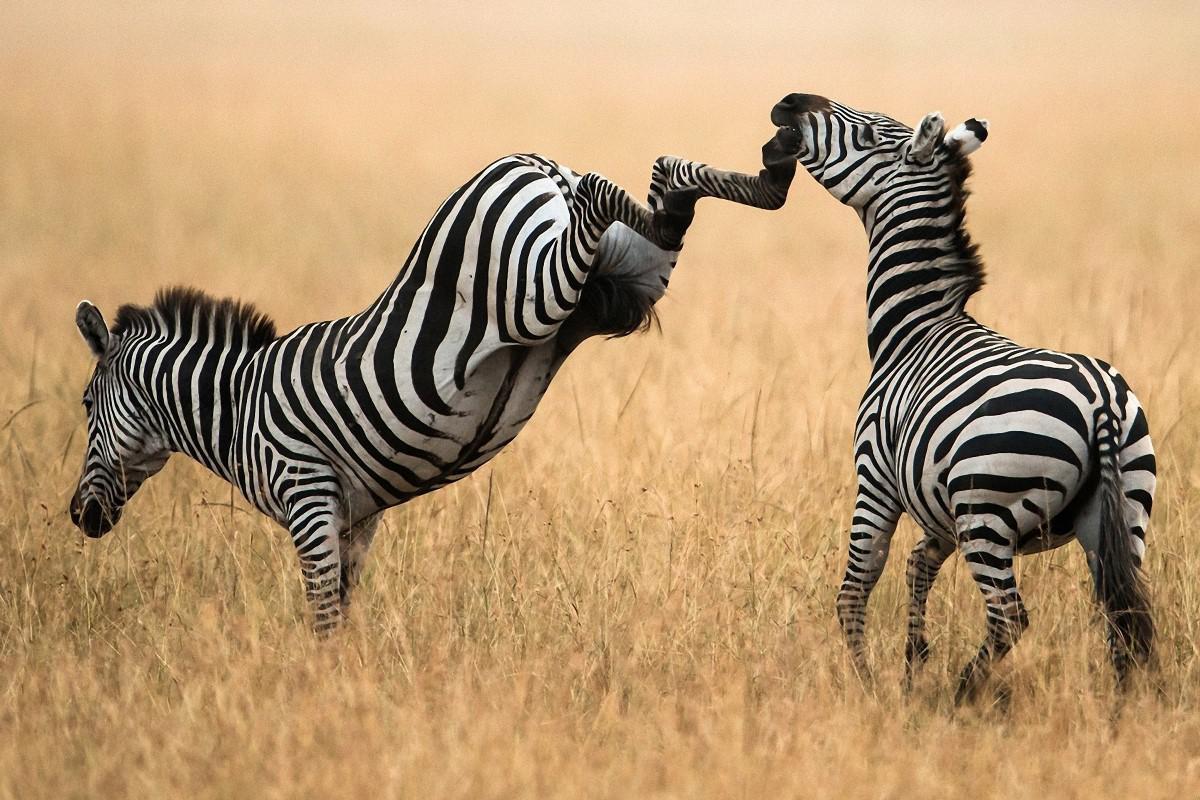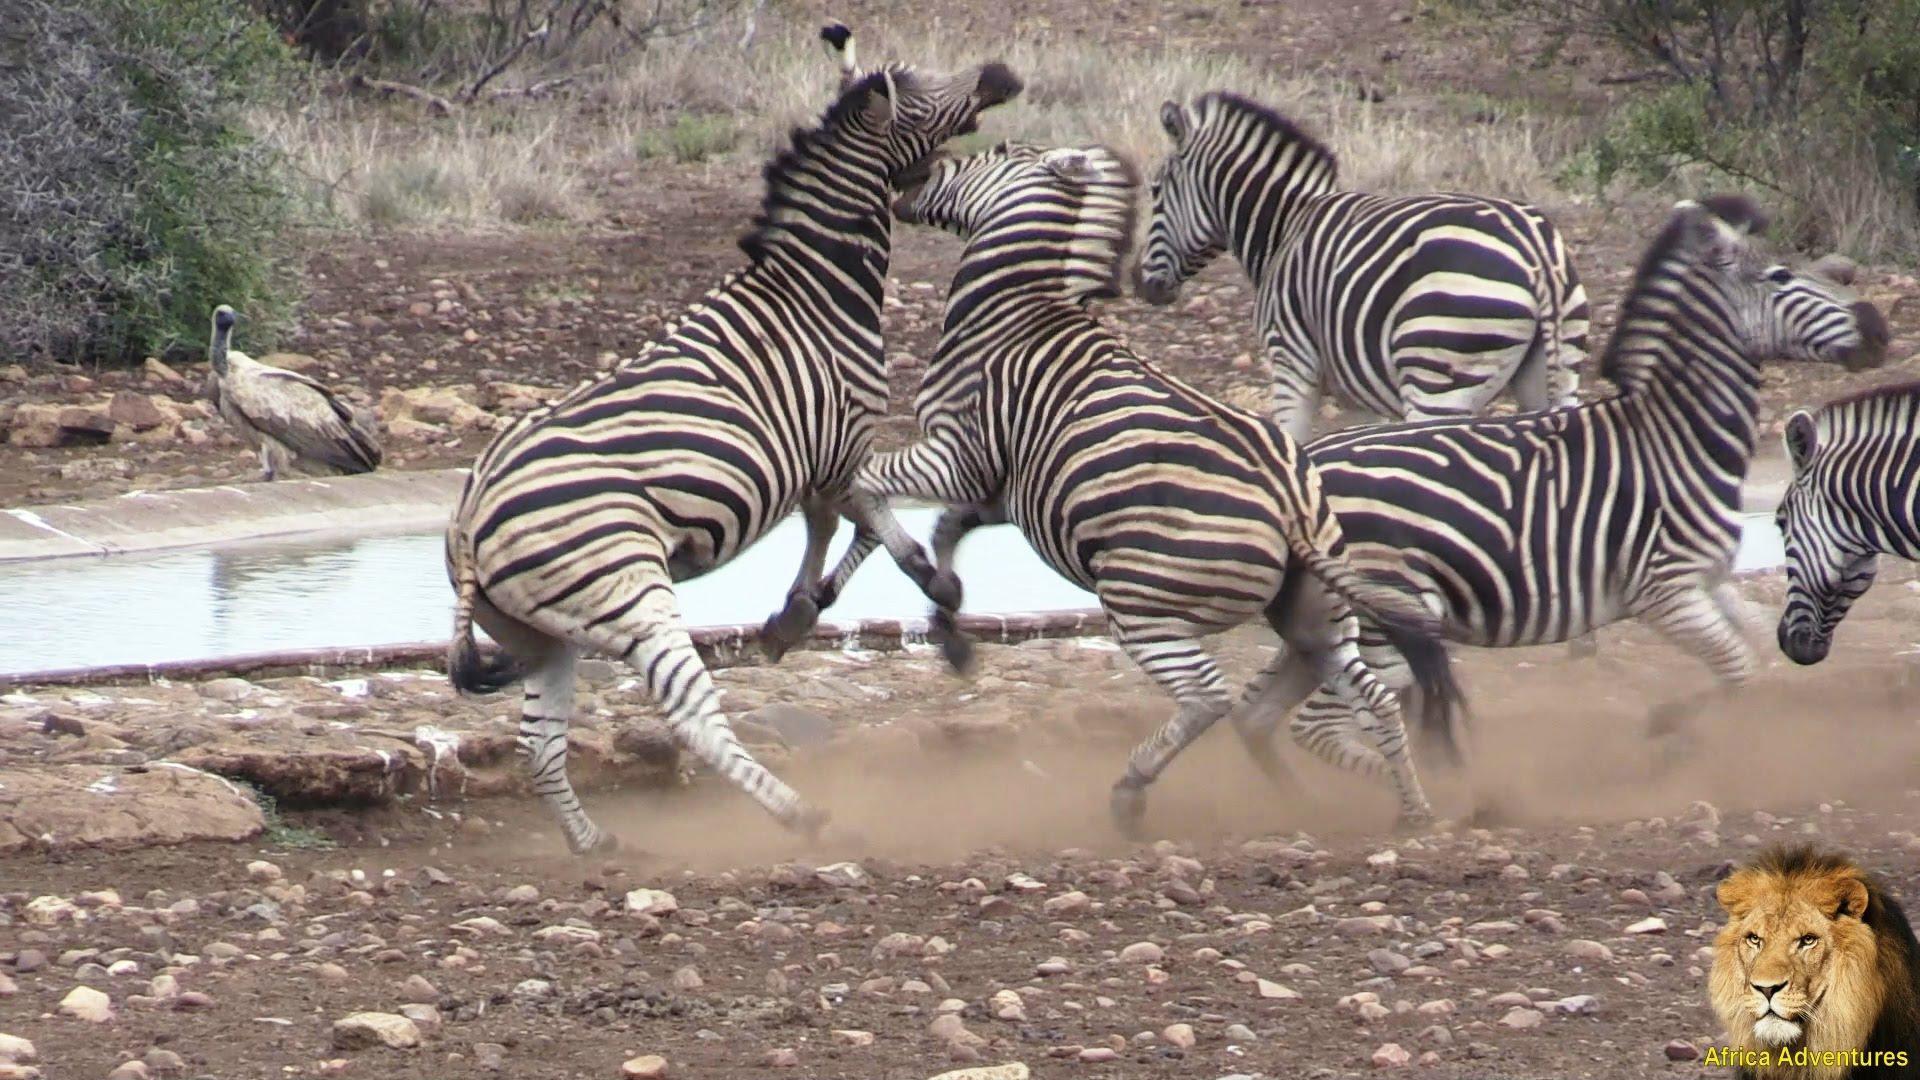The first image is the image on the left, the second image is the image on the right. Given the left and right images, does the statement "Both images show zebras fighting, though one has only two zebras and the other image has more." hold true? Answer yes or no. Yes. The first image is the image on the left, the second image is the image on the right. Given the left and right images, does the statement "In exactly one of the images there is at least one zebra with its front legs off the ground." hold true? Answer yes or no. Yes. 